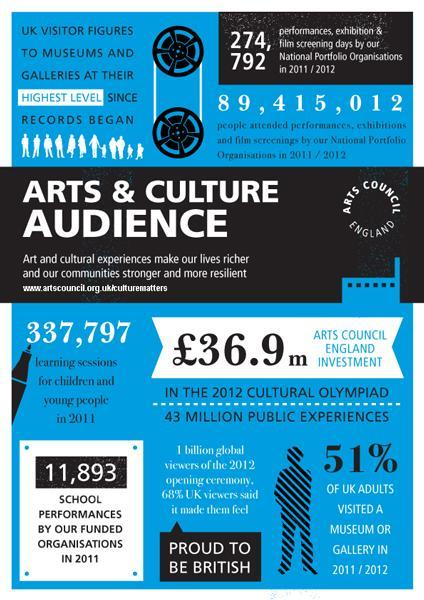How much money is invested by the Arts Council England in the 2012 cultural olympiad?
Answer the question with a short phrase. £36.9 m How many learning sessions were conducted for children & young people in UK in 2011? 337,797 What percentage of UK adults didn't visit a museum or gallery in 2011/2012? 49% How many school performances were organised by the funded organisations in UK in 2011? 11,893 How many performances, exhibition & film screening days were organised by the National Portfolio Organisations in UK in 2011/2012? 274,792 